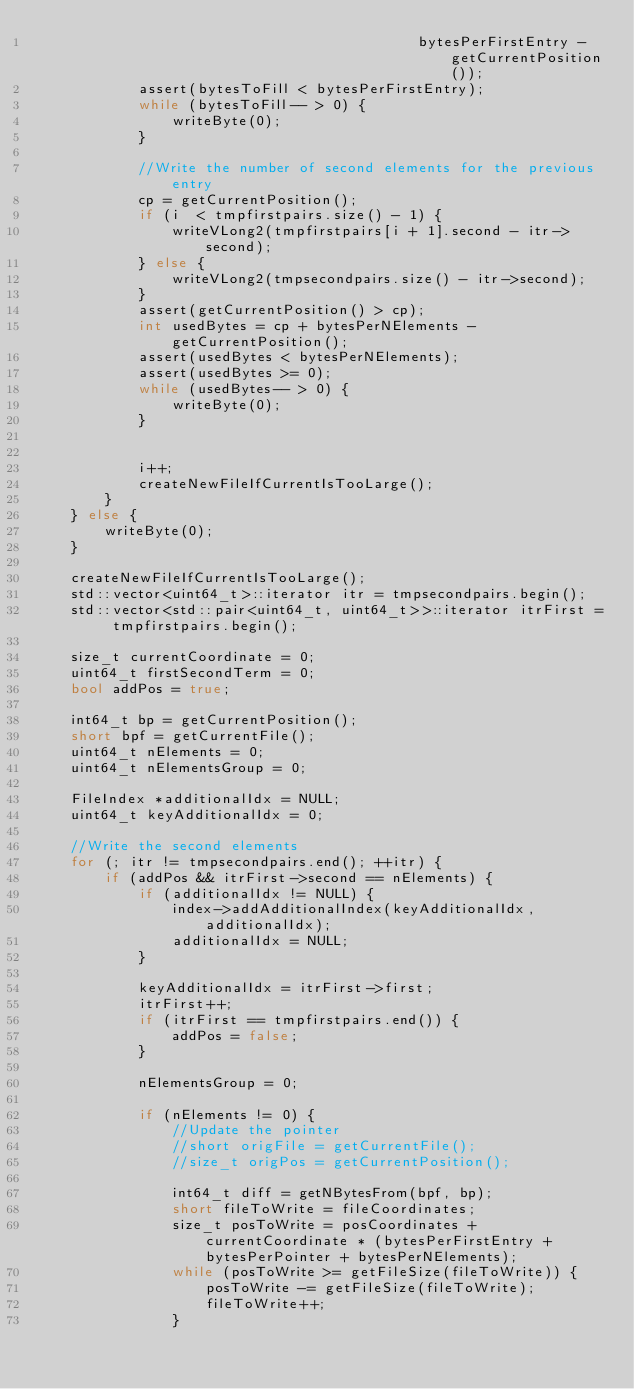Convert code to text. <code><loc_0><loc_0><loc_500><loc_500><_C++_>                                             bytesPerFirstEntry - getCurrentPosition());
            assert(bytesToFill < bytesPerFirstEntry);
            while (bytesToFill-- > 0) {
                writeByte(0);
            }

            //Write the number of second elements for the previous entry
            cp = getCurrentPosition();
            if (i  < tmpfirstpairs.size() - 1) {
                writeVLong2(tmpfirstpairs[i + 1].second - itr->second);
            } else {
                writeVLong2(tmpsecondpairs.size() - itr->second);
            }
            assert(getCurrentPosition() > cp);
            int usedBytes = cp + bytesPerNElements - getCurrentPosition();
            assert(usedBytes < bytesPerNElements);
            assert(usedBytes >= 0);
            while (usedBytes-- > 0) {
                writeByte(0);
            }


            i++;
            createNewFileIfCurrentIsTooLarge();
        }
    } else {
        writeByte(0);
    }

    createNewFileIfCurrentIsTooLarge();
    std::vector<uint64_t>::iterator itr = tmpsecondpairs.begin();
    std::vector<std::pair<uint64_t, uint64_t>>::iterator itrFirst = tmpfirstpairs.begin();

    size_t currentCoordinate = 0;
    uint64_t firstSecondTerm = 0;
    bool addPos = true;

    int64_t bp = getCurrentPosition();
    short bpf = getCurrentFile();
    uint64_t nElements = 0;
    uint64_t nElementsGroup = 0;

    FileIndex *additionalIdx = NULL;
    uint64_t keyAdditionalIdx = 0;

    //Write the second elements
    for (; itr != tmpsecondpairs.end(); ++itr) {
        if (addPos && itrFirst->second == nElements) {
            if (additionalIdx != NULL) {
                index->addAdditionalIndex(keyAdditionalIdx, additionalIdx);
                additionalIdx = NULL;
            }

            keyAdditionalIdx = itrFirst->first;
            itrFirst++;
            if (itrFirst == tmpfirstpairs.end()) {
                addPos = false;
            }

            nElementsGroup = 0;

            if (nElements != 0) {
                //Update the pointer
                //short origFile = getCurrentFile();
                //size_t origPos = getCurrentPosition();

                int64_t diff = getNBytesFrom(bpf, bp);
                short fileToWrite = fileCoordinates;
                size_t posToWrite = posCoordinates + currentCoordinate * (bytesPerFirstEntry + bytesPerPointer + bytesPerNElements);
                while (posToWrite >= getFileSize(fileToWrite)) {
                    posToWrite -= getFileSize(fileToWrite);
                    fileToWrite++;
                }</code> 